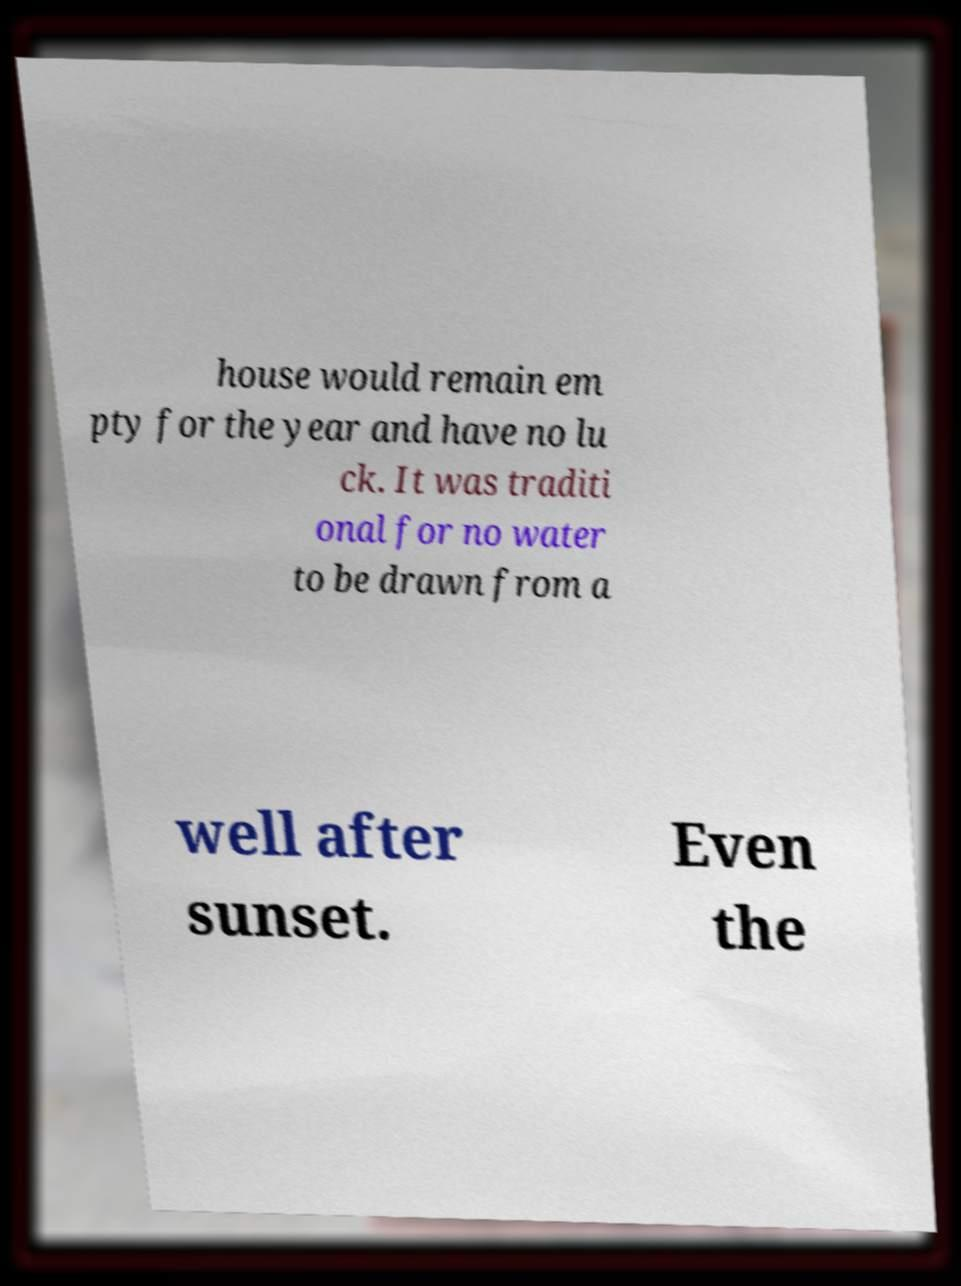Can you read and provide the text displayed in the image?This photo seems to have some interesting text. Can you extract and type it out for me? house would remain em pty for the year and have no lu ck. It was traditi onal for no water to be drawn from a well after sunset. Even the 